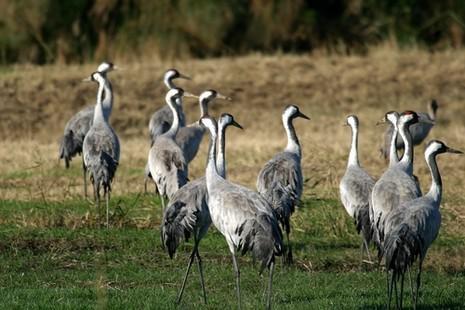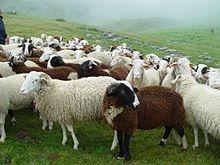The first image is the image on the left, the second image is the image on the right. Evaluate the accuracy of this statement regarding the images: "All of the birds are in or near the water.". Is it true? Answer yes or no. No. 